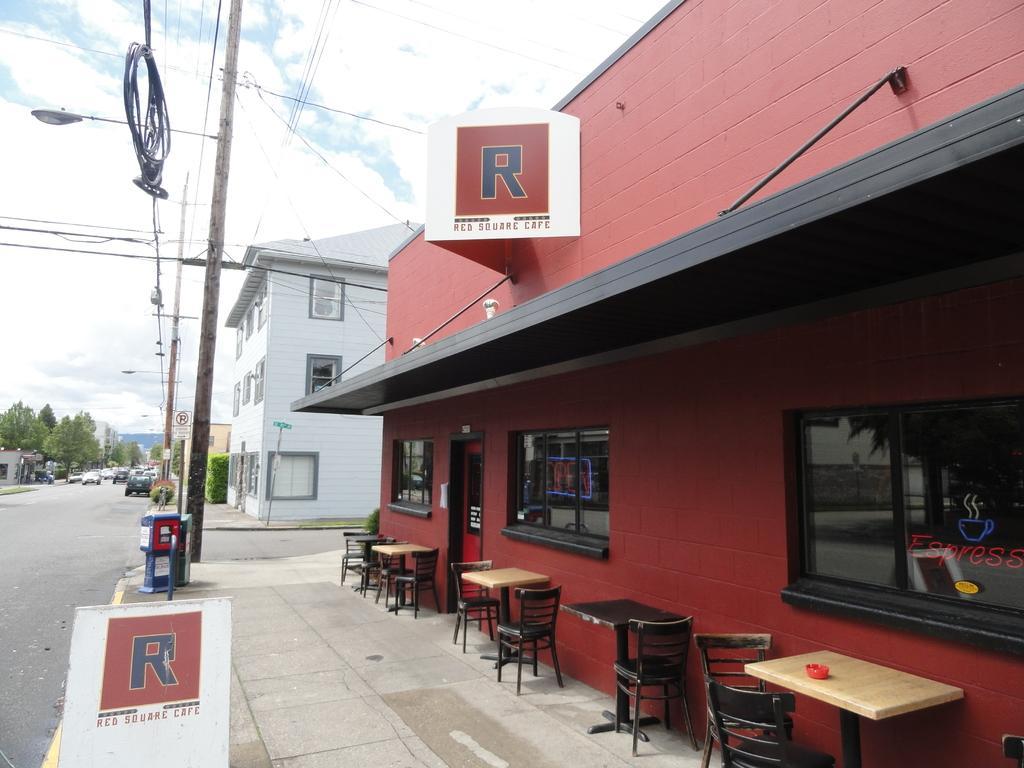Please provide a concise description of this image. In this image I can see a road, on the road there are vehicles, beside the road there are some trees visible and in front of house there are some chairs and table kept on floor and there is a pole and power line cable visible in front of floor at the top there is the sky. 